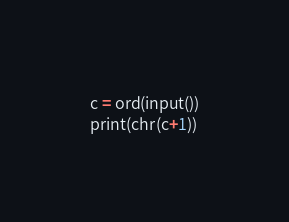<code> <loc_0><loc_0><loc_500><loc_500><_Python_>c = ord(input())
print(chr(c+1))
</code> 